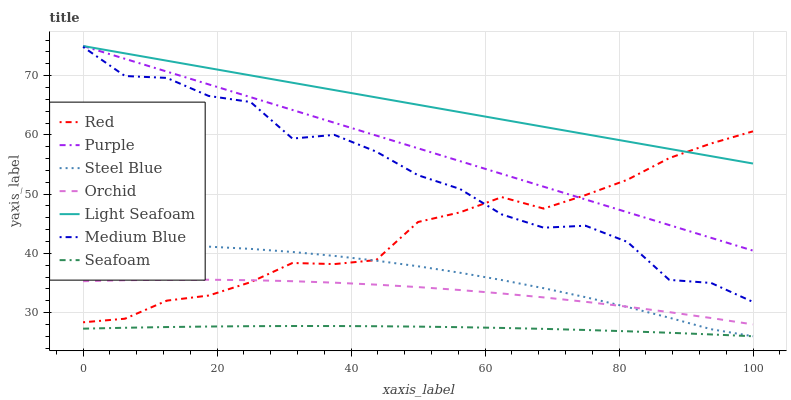Does Seafoam have the minimum area under the curve?
Answer yes or no. Yes. Does Light Seafoam have the maximum area under the curve?
Answer yes or no. Yes. Does Medium Blue have the minimum area under the curve?
Answer yes or no. No. Does Medium Blue have the maximum area under the curve?
Answer yes or no. No. Is Light Seafoam the smoothest?
Answer yes or no. Yes. Is Medium Blue the roughest?
Answer yes or no. Yes. Is Steel Blue the smoothest?
Answer yes or no. No. Is Steel Blue the roughest?
Answer yes or no. No. Does Steel Blue have the lowest value?
Answer yes or no. Yes. Does Medium Blue have the lowest value?
Answer yes or no. No. Does Light Seafoam have the highest value?
Answer yes or no. Yes. Does Medium Blue have the highest value?
Answer yes or no. No. Is Orchid less than Light Seafoam?
Answer yes or no. Yes. Is Purple greater than Medium Blue?
Answer yes or no. Yes. Does Purple intersect Light Seafoam?
Answer yes or no. Yes. Is Purple less than Light Seafoam?
Answer yes or no. No. Is Purple greater than Light Seafoam?
Answer yes or no. No. Does Orchid intersect Light Seafoam?
Answer yes or no. No. 